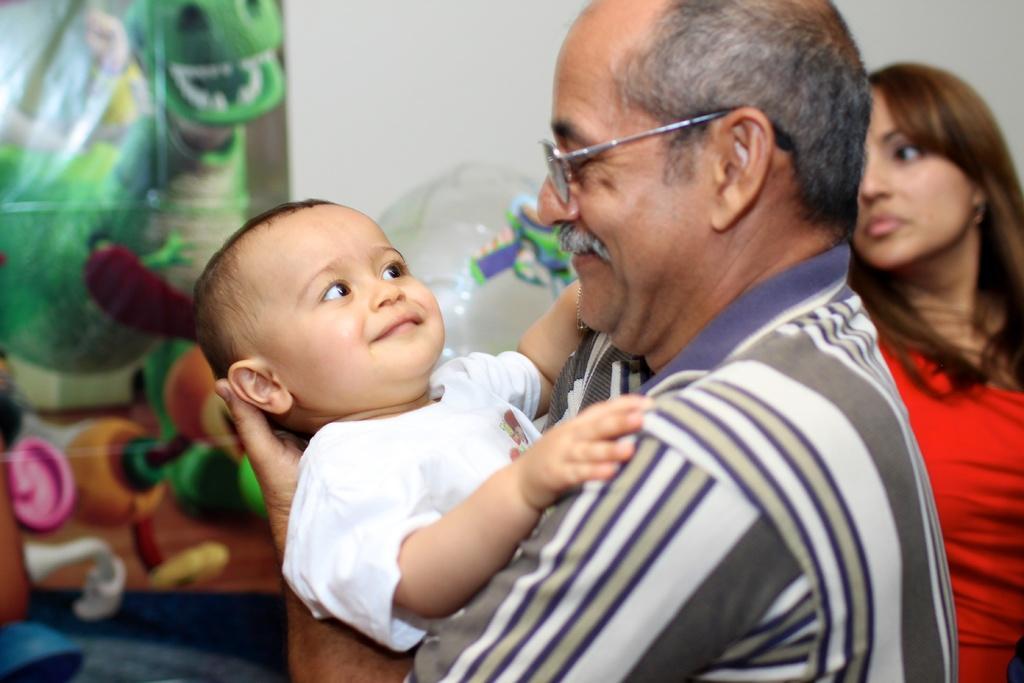Describe this image in one or two sentences. This picture is clicked inside. In the foreground there is a man holding a baby and seems to be standing. On the right corner there is a woman wearing a red color dress and standing. On the left we can see the picture of some animals. In the background there is a wall. 